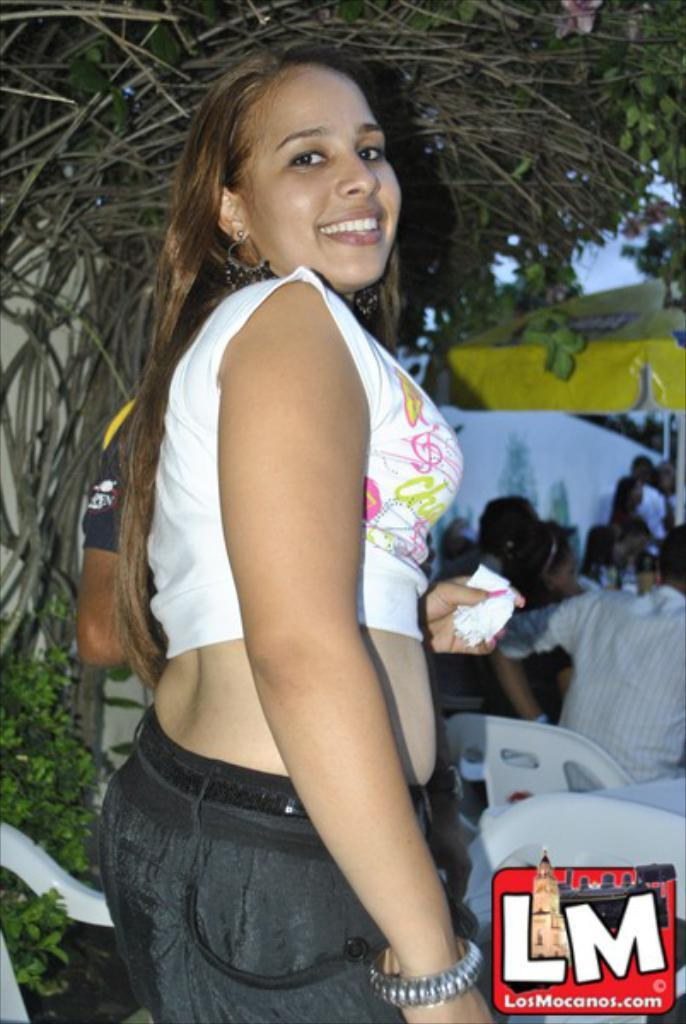Who is the main subject in the image? There is a woman in the image. Where is the woman located in the image? The woman is in the middle of the image. What is the woman's expression in the image? The woman is smiling in the image. What can be seen at the top of the image? There is a tree at the top of the image. What is present at the bottom of the image? There are chairs at the bottom of the image. Can you describe the people on the right side of the image? There are people sitting on chairs on the right side of the image. What type of cookware is the woman using to prepare a meal in the image? There is no cookware or meal preparation visible in the image; it features a woman smiling in the middle of the scene. 